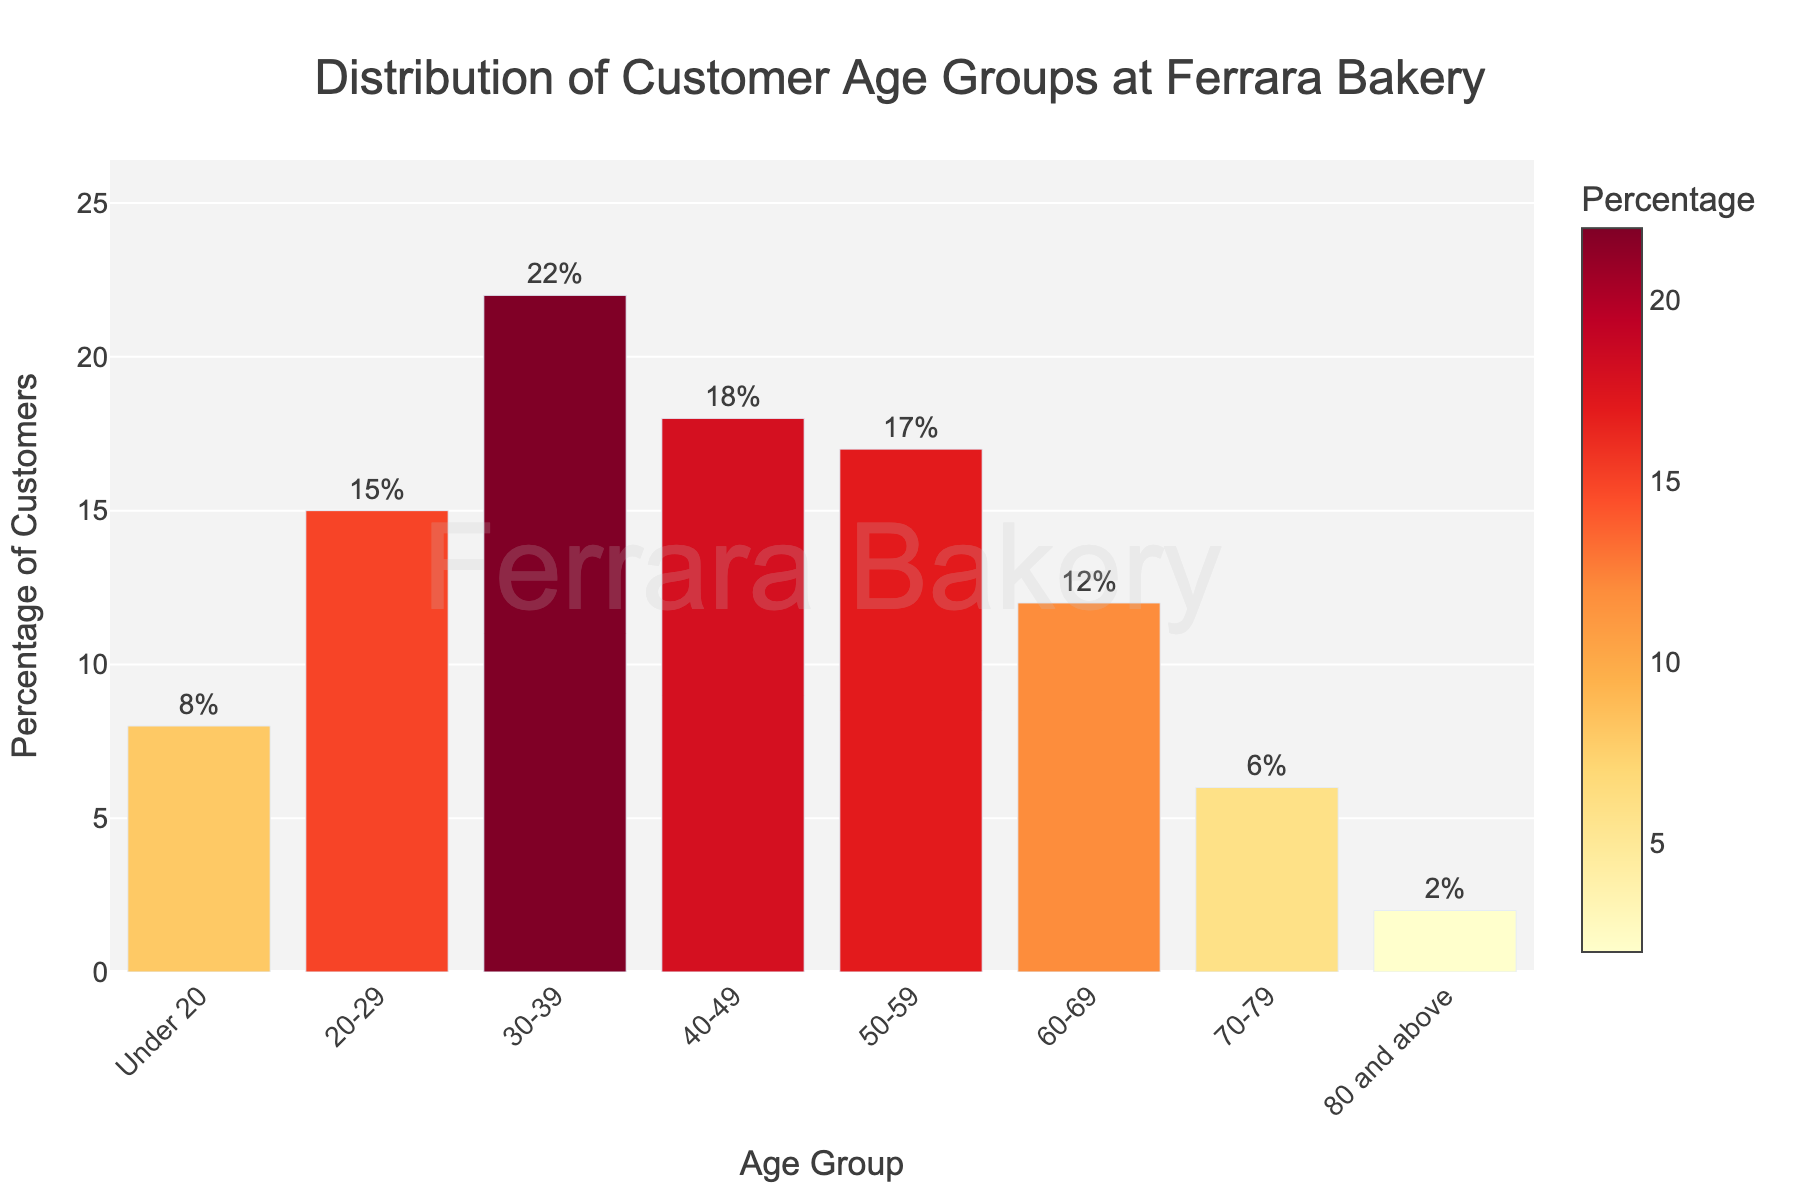Which age group has the highest percentage of customers? The age group with the highest percentage will have the tallest bar. The 30-39 age group has the tallest bar.
Answer: 30-39 Which age groups have a percentage of customers greater than 15%? Identify the bars that exceed the 15% mark. The age groups 20-29, 30-39, 40-49, and 50-59 fit this criterion.
Answer: 20-29, 30-39, 40-49, 50-59 What is the difference in percentage between the age groups 30-39 and 70-79? Subtract the percentage of the 70-79 age group from the percentage of the 30-39 age group (22% - 6%).
Answer: 16% How many age groups have less than 10% of the total customers? Count the bars that are shorter than the 10% mark. The age groups Under 20, 70-79, and 80 and above are included.
Answer: 3 What is the combined percentage of customers who are 60 years old or above? Add the percentages of the 60-69, 70-79, and 80 and above age groups (12% + 6% + 2%).
Answer: 20% Which age group has the smallest percentage of customers? The age group with the shortest bar is the 80 and above category with 2%.
Answer: 80 and above Are there more customers in the 40-49 or 60-69 age group? Compare the heights of the bars for 40-49 and 60-69. The 40-49 group has a taller bar indicating a higher percentage.
Answer: 40-49 What is the average percentage of customers in the age groups from 20-29 to 50-59? Add the percentages of the age groups 20-29, 30-39, 40-49, and 50-59, and divide by 4 (15% + 22% + 18% + 17%) / 4.
Answer: 18% Which age group(s) are within 2% of 15%? Identify age groups whose customer percentages are between 13% and 17%. The 20-29 (15%) and 50-59 (17%) age groups qualify.
Answer: 20-29, 50-59 